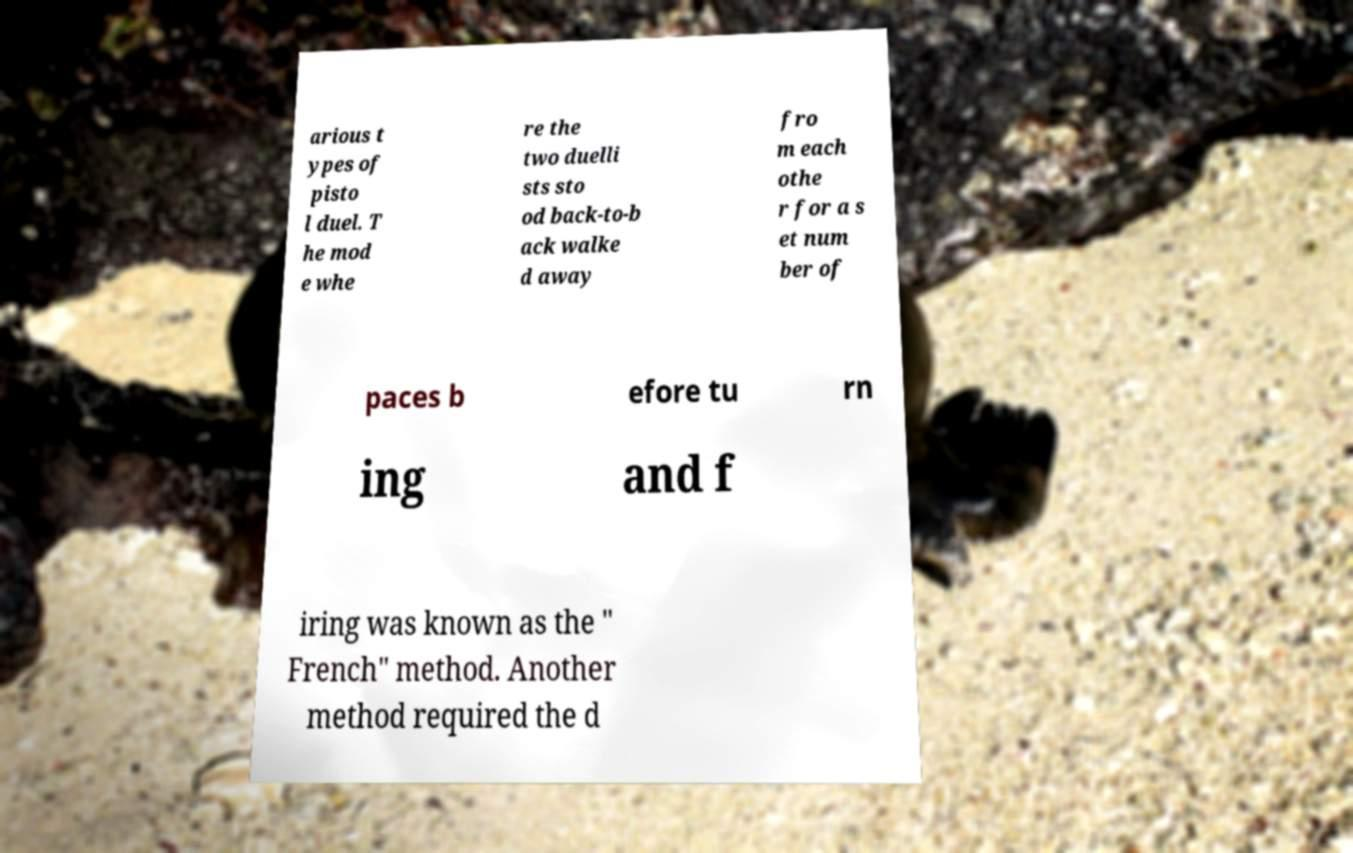What messages or text are displayed in this image? I need them in a readable, typed format. arious t ypes of pisto l duel. T he mod e whe re the two duelli sts sto od back-to-b ack walke d away fro m each othe r for a s et num ber of paces b efore tu rn ing and f iring was known as the " French" method. Another method required the d 